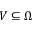<formula> <loc_0><loc_0><loc_500><loc_500>V \subseteq \Omega</formula> 